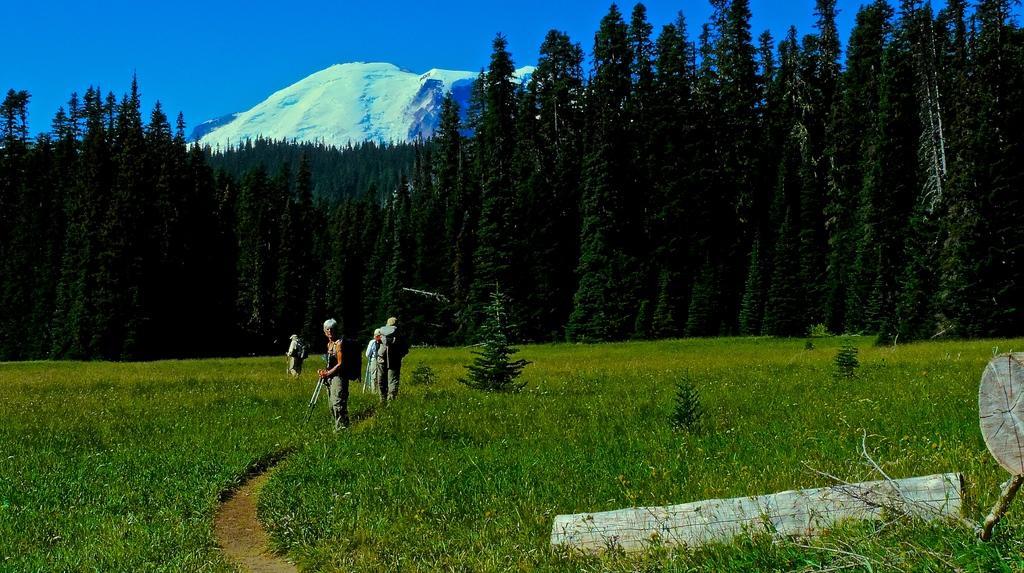In one or two sentences, can you explain what this image depicts? In this image, we can see persons wearing clothes. There are some plants on the ground. There are trees in the middle of the image. There are cut woods in the bottom right of the image. There is a hill and sky at the top of the image. 